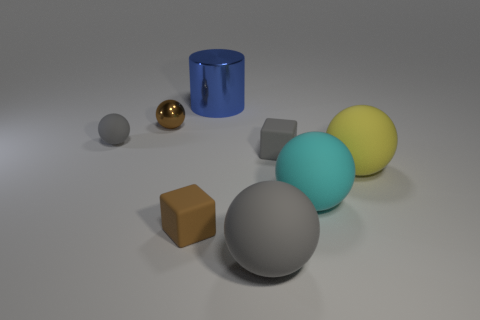How many objects are cyan shiny objects or gray rubber objects to the right of the small rubber ball?
Make the answer very short. 2. There is a blue thing that is the same size as the cyan rubber sphere; what material is it?
Offer a very short reply. Metal. Does the yellow thing have the same material as the small brown sphere?
Make the answer very short. No. There is a tiny thing that is both on the left side of the tiny brown cube and in front of the tiny shiny sphere; what is its color?
Offer a very short reply. Gray. There is a rubber block on the right side of the brown rubber block; is it the same color as the tiny matte sphere?
Provide a short and direct response. Yes. The cyan rubber object that is the same size as the shiny cylinder is what shape?
Give a very brief answer. Sphere. How many other things are there of the same color as the big metallic thing?
Provide a succinct answer. 0. What number of other objects are there of the same material as the big cylinder?
Offer a terse response. 1. Do the yellow object and the matte block that is in front of the tiny gray block have the same size?
Your answer should be compact. No. The large shiny object has what color?
Offer a very short reply. Blue. 